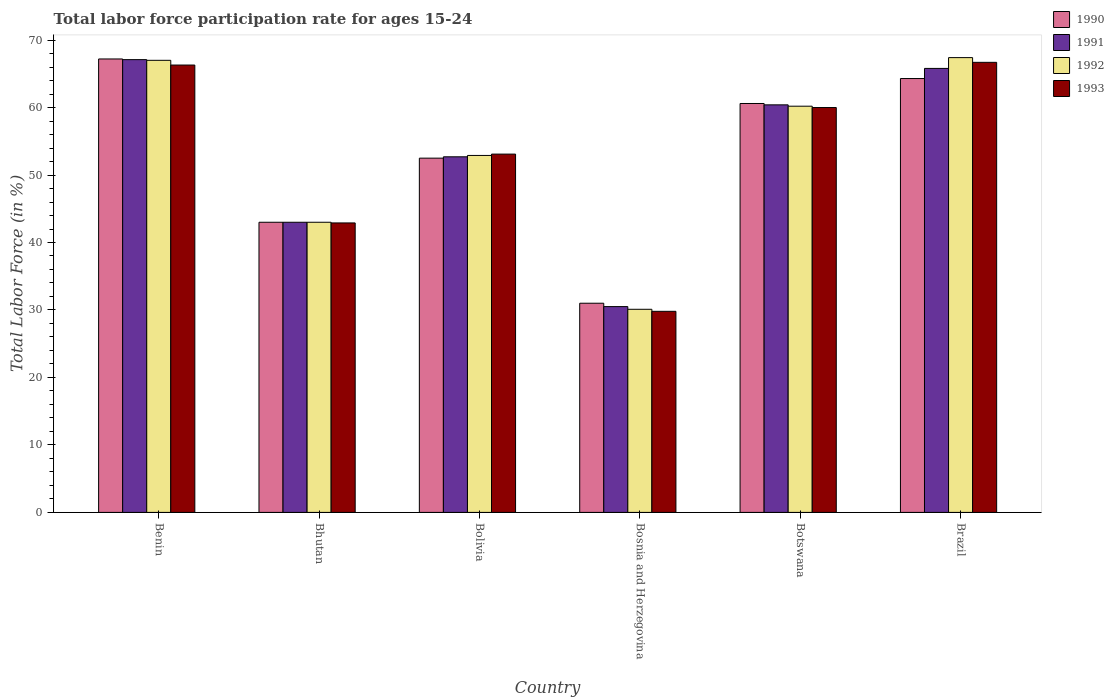How many different coloured bars are there?
Offer a very short reply. 4. How many groups of bars are there?
Offer a very short reply. 6. Are the number of bars per tick equal to the number of legend labels?
Make the answer very short. Yes. Are the number of bars on each tick of the X-axis equal?
Your answer should be compact. Yes. How many bars are there on the 1st tick from the right?
Your response must be concise. 4. What is the label of the 2nd group of bars from the left?
Offer a terse response. Bhutan. In how many cases, is the number of bars for a given country not equal to the number of legend labels?
Provide a succinct answer. 0. What is the labor force participation rate in 1990 in Brazil?
Offer a very short reply. 64.3. Across all countries, what is the maximum labor force participation rate in 1992?
Your response must be concise. 67.4. Across all countries, what is the minimum labor force participation rate in 1993?
Your answer should be very brief. 29.8. In which country was the labor force participation rate in 1990 minimum?
Make the answer very short. Bosnia and Herzegovina. What is the total labor force participation rate in 1993 in the graph?
Provide a short and direct response. 318.8. What is the difference between the labor force participation rate in 1992 in Bosnia and Herzegovina and that in Botswana?
Provide a succinct answer. -30.1. What is the difference between the labor force participation rate in 1991 in Botswana and the labor force participation rate in 1993 in Benin?
Give a very brief answer. -5.9. What is the average labor force participation rate in 1993 per country?
Offer a very short reply. 53.13. What is the difference between the labor force participation rate of/in 1990 and labor force participation rate of/in 1993 in Bosnia and Herzegovina?
Give a very brief answer. 1.2. What is the ratio of the labor force participation rate in 1992 in Botswana to that in Brazil?
Offer a terse response. 0.89. Is the labor force participation rate in 1992 in Bolivia less than that in Bosnia and Herzegovina?
Offer a very short reply. No. What is the difference between the highest and the second highest labor force participation rate in 1991?
Provide a short and direct response. -1.3. What is the difference between the highest and the lowest labor force participation rate in 1990?
Your answer should be very brief. 36.2. In how many countries, is the labor force participation rate in 1993 greater than the average labor force participation rate in 1993 taken over all countries?
Provide a short and direct response. 3. Is the sum of the labor force participation rate in 1993 in Bhutan and Brazil greater than the maximum labor force participation rate in 1991 across all countries?
Your answer should be very brief. Yes. Is it the case that in every country, the sum of the labor force participation rate in 1992 and labor force participation rate in 1993 is greater than the sum of labor force participation rate in 1990 and labor force participation rate in 1991?
Provide a succinct answer. No. What does the 2nd bar from the left in Botswana represents?
Ensure brevity in your answer.  1991. How many bars are there?
Offer a terse response. 24. What is the difference between two consecutive major ticks on the Y-axis?
Give a very brief answer. 10. Are the values on the major ticks of Y-axis written in scientific E-notation?
Offer a terse response. No. Does the graph contain any zero values?
Make the answer very short. No. Does the graph contain grids?
Keep it short and to the point. No. Where does the legend appear in the graph?
Give a very brief answer. Top right. How are the legend labels stacked?
Your response must be concise. Vertical. What is the title of the graph?
Ensure brevity in your answer.  Total labor force participation rate for ages 15-24. Does "1999" appear as one of the legend labels in the graph?
Provide a short and direct response. No. What is the label or title of the Y-axis?
Provide a succinct answer. Total Labor Force (in %). What is the Total Labor Force (in %) of 1990 in Benin?
Your answer should be very brief. 67.2. What is the Total Labor Force (in %) in 1991 in Benin?
Make the answer very short. 67.1. What is the Total Labor Force (in %) in 1993 in Benin?
Provide a succinct answer. 66.3. What is the Total Labor Force (in %) of 1992 in Bhutan?
Give a very brief answer. 43. What is the Total Labor Force (in %) of 1993 in Bhutan?
Your answer should be very brief. 42.9. What is the Total Labor Force (in %) in 1990 in Bolivia?
Offer a terse response. 52.5. What is the Total Labor Force (in %) in 1991 in Bolivia?
Give a very brief answer. 52.7. What is the Total Labor Force (in %) of 1992 in Bolivia?
Provide a short and direct response. 52.9. What is the Total Labor Force (in %) of 1993 in Bolivia?
Your response must be concise. 53.1. What is the Total Labor Force (in %) in 1990 in Bosnia and Herzegovina?
Offer a terse response. 31. What is the Total Labor Force (in %) of 1991 in Bosnia and Herzegovina?
Offer a very short reply. 30.5. What is the Total Labor Force (in %) in 1992 in Bosnia and Herzegovina?
Your answer should be very brief. 30.1. What is the Total Labor Force (in %) in 1993 in Bosnia and Herzegovina?
Give a very brief answer. 29.8. What is the Total Labor Force (in %) in 1990 in Botswana?
Give a very brief answer. 60.6. What is the Total Labor Force (in %) of 1991 in Botswana?
Offer a terse response. 60.4. What is the Total Labor Force (in %) of 1992 in Botswana?
Ensure brevity in your answer.  60.2. What is the Total Labor Force (in %) of 1990 in Brazil?
Offer a terse response. 64.3. What is the Total Labor Force (in %) of 1991 in Brazil?
Keep it short and to the point. 65.8. What is the Total Labor Force (in %) of 1992 in Brazil?
Make the answer very short. 67.4. What is the Total Labor Force (in %) of 1993 in Brazil?
Your answer should be compact. 66.7. Across all countries, what is the maximum Total Labor Force (in %) in 1990?
Give a very brief answer. 67.2. Across all countries, what is the maximum Total Labor Force (in %) of 1991?
Give a very brief answer. 67.1. Across all countries, what is the maximum Total Labor Force (in %) of 1992?
Ensure brevity in your answer.  67.4. Across all countries, what is the maximum Total Labor Force (in %) of 1993?
Provide a short and direct response. 66.7. Across all countries, what is the minimum Total Labor Force (in %) in 1991?
Your answer should be very brief. 30.5. Across all countries, what is the minimum Total Labor Force (in %) of 1992?
Provide a short and direct response. 30.1. Across all countries, what is the minimum Total Labor Force (in %) of 1993?
Your answer should be compact. 29.8. What is the total Total Labor Force (in %) of 1990 in the graph?
Offer a very short reply. 318.6. What is the total Total Labor Force (in %) in 1991 in the graph?
Offer a very short reply. 319.5. What is the total Total Labor Force (in %) in 1992 in the graph?
Offer a terse response. 320.6. What is the total Total Labor Force (in %) of 1993 in the graph?
Your answer should be compact. 318.8. What is the difference between the Total Labor Force (in %) of 1990 in Benin and that in Bhutan?
Your answer should be compact. 24.2. What is the difference between the Total Labor Force (in %) of 1991 in Benin and that in Bhutan?
Offer a terse response. 24.1. What is the difference between the Total Labor Force (in %) in 1992 in Benin and that in Bhutan?
Ensure brevity in your answer.  24. What is the difference between the Total Labor Force (in %) in 1993 in Benin and that in Bhutan?
Your answer should be compact. 23.4. What is the difference between the Total Labor Force (in %) of 1992 in Benin and that in Bolivia?
Offer a terse response. 14.1. What is the difference between the Total Labor Force (in %) in 1993 in Benin and that in Bolivia?
Offer a terse response. 13.2. What is the difference between the Total Labor Force (in %) in 1990 in Benin and that in Bosnia and Herzegovina?
Your answer should be compact. 36.2. What is the difference between the Total Labor Force (in %) in 1991 in Benin and that in Bosnia and Herzegovina?
Offer a terse response. 36.6. What is the difference between the Total Labor Force (in %) of 1992 in Benin and that in Bosnia and Herzegovina?
Offer a very short reply. 36.9. What is the difference between the Total Labor Force (in %) in 1993 in Benin and that in Bosnia and Herzegovina?
Offer a very short reply. 36.5. What is the difference between the Total Labor Force (in %) in 1991 in Benin and that in Botswana?
Your answer should be compact. 6.7. What is the difference between the Total Labor Force (in %) in 1993 in Benin and that in Botswana?
Make the answer very short. 6.3. What is the difference between the Total Labor Force (in %) of 1992 in Benin and that in Brazil?
Make the answer very short. -0.4. What is the difference between the Total Labor Force (in %) of 1993 in Benin and that in Brazil?
Give a very brief answer. -0.4. What is the difference between the Total Labor Force (in %) of 1990 in Bhutan and that in Bolivia?
Ensure brevity in your answer.  -9.5. What is the difference between the Total Labor Force (in %) of 1991 in Bhutan and that in Bolivia?
Offer a terse response. -9.7. What is the difference between the Total Labor Force (in %) of 1990 in Bhutan and that in Botswana?
Provide a short and direct response. -17.6. What is the difference between the Total Labor Force (in %) in 1991 in Bhutan and that in Botswana?
Provide a short and direct response. -17.4. What is the difference between the Total Labor Force (in %) in 1992 in Bhutan and that in Botswana?
Ensure brevity in your answer.  -17.2. What is the difference between the Total Labor Force (in %) in 1993 in Bhutan and that in Botswana?
Provide a short and direct response. -17.1. What is the difference between the Total Labor Force (in %) of 1990 in Bhutan and that in Brazil?
Keep it short and to the point. -21.3. What is the difference between the Total Labor Force (in %) in 1991 in Bhutan and that in Brazil?
Offer a terse response. -22.8. What is the difference between the Total Labor Force (in %) of 1992 in Bhutan and that in Brazil?
Your response must be concise. -24.4. What is the difference between the Total Labor Force (in %) of 1993 in Bhutan and that in Brazil?
Offer a terse response. -23.8. What is the difference between the Total Labor Force (in %) in 1992 in Bolivia and that in Bosnia and Herzegovina?
Your answer should be compact. 22.8. What is the difference between the Total Labor Force (in %) in 1993 in Bolivia and that in Bosnia and Herzegovina?
Offer a terse response. 23.3. What is the difference between the Total Labor Force (in %) of 1990 in Bolivia and that in Botswana?
Offer a very short reply. -8.1. What is the difference between the Total Labor Force (in %) in 1992 in Bolivia and that in Botswana?
Your response must be concise. -7.3. What is the difference between the Total Labor Force (in %) of 1993 in Bolivia and that in Botswana?
Ensure brevity in your answer.  -6.9. What is the difference between the Total Labor Force (in %) in 1992 in Bolivia and that in Brazil?
Keep it short and to the point. -14.5. What is the difference between the Total Labor Force (in %) of 1993 in Bolivia and that in Brazil?
Give a very brief answer. -13.6. What is the difference between the Total Labor Force (in %) of 1990 in Bosnia and Herzegovina and that in Botswana?
Keep it short and to the point. -29.6. What is the difference between the Total Labor Force (in %) of 1991 in Bosnia and Herzegovina and that in Botswana?
Make the answer very short. -29.9. What is the difference between the Total Labor Force (in %) in 1992 in Bosnia and Herzegovina and that in Botswana?
Ensure brevity in your answer.  -30.1. What is the difference between the Total Labor Force (in %) in 1993 in Bosnia and Herzegovina and that in Botswana?
Your answer should be very brief. -30.2. What is the difference between the Total Labor Force (in %) in 1990 in Bosnia and Herzegovina and that in Brazil?
Your answer should be very brief. -33.3. What is the difference between the Total Labor Force (in %) in 1991 in Bosnia and Herzegovina and that in Brazil?
Your answer should be very brief. -35.3. What is the difference between the Total Labor Force (in %) of 1992 in Bosnia and Herzegovina and that in Brazil?
Provide a succinct answer. -37.3. What is the difference between the Total Labor Force (in %) of 1993 in Bosnia and Herzegovina and that in Brazil?
Your response must be concise. -36.9. What is the difference between the Total Labor Force (in %) in 1990 in Botswana and that in Brazil?
Make the answer very short. -3.7. What is the difference between the Total Labor Force (in %) in 1990 in Benin and the Total Labor Force (in %) in 1991 in Bhutan?
Make the answer very short. 24.2. What is the difference between the Total Labor Force (in %) of 1990 in Benin and the Total Labor Force (in %) of 1992 in Bhutan?
Offer a very short reply. 24.2. What is the difference between the Total Labor Force (in %) in 1990 in Benin and the Total Labor Force (in %) in 1993 in Bhutan?
Make the answer very short. 24.3. What is the difference between the Total Labor Force (in %) of 1991 in Benin and the Total Labor Force (in %) of 1992 in Bhutan?
Offer a terse response. 24.1. What is the difference between the Total Labor Force (in %) in 1991 in Benin and the Total Labor Force (in %) in 1993 in Bhutan?
Provide a succinct answer. 24.2. What is the difference between the Total Labor Force (in %) of 1992 in Benin and the Total Labor Force (in %) of 1993 in Bhutan?
Your response must be concise. 24.1. What is the difference between the Total Labor Force (in %) of 1990 in Benin and the Total Labor Force (in %) of 1992 in Bolivia?
Your answer should be compact. 14.3. What is the difference between the Total Labor Force (in %) of 1990 in Benin and the Total Labor Force (in %) of 1991 in Bosnia and Herzegovina?
Ensure brevity in your answer.  36.7. What is the difference between the Total Labor Force (in %) in 1990 in Benin and the Total Labor Force (in %) in 1992 in Bosnia and Herzegovina?
Keep it short and to the point. 37.1. What is the difference between the Total Labor Force (in %) of 1990 in Benin and the Total Labor Force (in %) of 1993 in Bosnia and Herzegovina?
Your answer should be very brief. 37.4. What is the difference between the Total Labor Force (in %) of 1991 in Benin and the Total Labor Force (in %) of 1992 in Bosnia and Herzegovina?
Your answer should be compact. 37. What is the difference between the Total Labor Force (in %) of 1991 in Benin and the Total Labor Force (in %) of 1993 in Bosnia and Herzegovina?
Make the answer very short. 37.3. What is the difference between the Total Labor Force (in %) of 1992 in Benin and the Total Labor Force (in %) of 1993 in Bosnia and Herzegovina?
Your answer should be compact. 37.2. What is the difference between the Total Labor Force (in %) of 1990 in Benin and the Total Labor Force (in %) of 1991 in Botswana?
Keep it short and to the point. 6.8. What is the difference between the Total Labor Force (in %) in 1991 in Benin and the Total Labor Force (in %) in 1992 in Botswana?
Ensure brevity in your answer.  6.9. What is the difference between the Total Labor Force (in %) in 1991 in Benin and the Total Labor Force (in %) in 1993 in Botswana?
Provide a succinct answer. 7.1. What is the difference between the Total Labor Force (in %) in 1990 in Benin and the Total Labor Force (in %) in 1991 in Brazil?
Make the answer very short. 1.4. What is the difference between the Total Labor Force (in %) of 1991 in Benin and the Total Labor Force (in %) of 1992 in Brazil?
Your answer should be very brief. -0.3. What is the difference between the Total Labor Force (in %) in 1991 in Benin and the Total Labor Force (in %) in 1993 in Brazil?
Provide a short and direct response. 0.4. What is the difference between the Total Labor Force (in %) of 1992 in Bhutan and the Total Labor Force (in %) of 1993 in Bolivia?
Ensure brevity in your answer.  -10.1. What is the difference between the Total Labor Force (in %) of 1990 in Bhutan and the Total Labor Force (in %) of 1993 in Bosnia and Herzegovina?
Provide a short and direct response. 13.2. What is the difference between the Total Labor Force (in %) of 1991 in Bhutan and the Total Labor Force (in %) of 1992 in Bosnia and Herzegovina?
Ensure brevity in your answer.  12.9. What is the difference between the Total Labor Force (in %) in 1991 in Bhutan and the Total Labor Force (in %) in 1993 in Bosnia and Herzegovina?
Your response must be concise. 13.2. What is the difference between the Total Labor Force (in %) of 1990 in Bhutan and the Total Labor Force (in %) of 1991 in Botswana?
Provide a succinct answer. -17.4. What is the difference between the Total Labor Force (in %) in 1990 in Bhutan and the Total Labor Force (in %) in 1992 in Botswana?
Your answer should be very brief. -17.2. What is the difference between the Total Labor Force (in %) in 1991 in Bhutan and the Total Labor Force (in %) in 1992 in Botswana?
Make the answer very short. -17.2. What is the difference between the Total Labor Force (in %) in 1990 in Bhutan and the Total Labor Force (in %) in 1991 in Brazil?
Your response must be concise. -22.8. What is the difference between the Total Labor Force (in %) in 1990 in Bhutan and the Total Labor Force (in %) in 1992 in Brazil?
Ensure brevity in your answer.  -24.4. What is the difference between the Total Labor Force (in %) of 1990 in Bhutan and the Total Labor Force (in %) of 1993 in Brazil?
Make the answer very short. -23.7. What is the difference between the Total Labor Force (in %) of 1991 in Bhutan and the Total Labor Force (in %) of 1992 in Brazil?
Your response must be concise. -24.4. What is the difference between the Total Labor Force (in %) of 1991 in Bhutan and the Total Labor Force (in %) of 1993 in Brazil?
Ensure brevity in your answer.  -23.7. What is the difference between the Total Labor Force (in %) of 1992 in Bhutan and the Total Labor Force (in %) of 1993 in Brazil?
Give a very brief answer. -23.7. What is the difference between the Total Labor Force (in %) of 1990 in Bolivia and the Total Labor Force (in %) of 1991 in Bosnia and Herzegovina?
Your answer should be very brief. 22. What is the difference between the Total Labor Force (in %) in 1990 in Bolivia and the Total Labor Force (in %) in 1992 in Bosnia and Herzegovina?
Offer a terse response. 22.4. What is the difference between the Total Labor Force (in %) in 1990 in Bolivia and the Total Labor Force (in %) in 1993 in Bosnia and Herzegovina?
Keep it short and to the point. 22.7. What is the difference between the Total Labor Force (in %) in 1991 in Bolivia and the Total Labor Force (in %) in 1992 in Bosnia and Herzegovina?
Your response must be concise. 22.6. What is the difference between the Total Labor Force (in %) of 1991 in Bolivia and the Total Labor Force (in %) of 1993 in Bosnia and Herzegovina?
Make the answer very short. 22.9. What is the difference between the Total Labor Force (in %) in 1992 in Bolivia and the Total Labor Force (in %) in 1993 in Bosnia and Herzegovina?
Make the answer very short. 23.1. What is the difference between the Total Labor Force (in %) of 1990 in Bolivia and the Total Labor Force (in %) of 1991 in Botswana?
Your answer should be very brief. -7.9. What is the difference between the Total Labor Force (in %) in 1990 in Bolivia and the Total Labor Force (in %) in 1992 in Botswana?
Make the answer very short. -7.7. What is the difference between the Total Labor Force (in %) of 1991 in Bolivia and the Total Labor Force (in %) of 1993 in Botswana?
Provide a short and direct response. -7.3. What is the difference between the Total Labor Force (in %) in 1990 in Bolivia and the Total Labor Force (in %) in 1992 in Brazil?
Make the answer very short. -14.9. What is the difference between the Total Labor Force (in %) of 1991 in Bolivia and the Total Labor Force (in %) of 1992 in Brazil?
Make the answer very short. -14.7. What is the difference between the Total Labor Force (in %) of 1991 in Bolivia and the Total Labor Force (in %) of 1993 in Brazil?
Ensure brevity in your answer.  -14. What is the difference between the Total Labor Force (in %) in 1992 in Bolivia and the Total Labor Force (in %) in 1993 in Brazil?
Provide a short and direct response. -13.8. What is the difference between the Total Labor Force (in %) in 1990 in Bosnia and Herzegovina and the Total Labor Force (in %) in 1991 in Botswana?
Provide a succinct answer. -29.4. What is the difference between the Total Labor Force (in %) of 1990 in Bosnia and Herzegovina and the Total Labor Force (in %) of 1992 in Botswana?
Offer a very short reply. -29.2. What is the difference between the Total Labor Force (in %) of 1990 in Bosnia and Herzegovina and the Total Labor Force (in %) of 1993 in Botswana?
Offer a terse response. -29. What is the difference between the Total Labor Force (in %) of 1991 in Bosnia and Herzegovina and the Total Labor Force (in %) of 1992 in Botswana?
Make the answer very short. -29.7. What is the difference between the Total Labor Force (in %) in 1991 in Bosnia and Herzegovina and the Total Labor Force (in %) in 1993 in Botswana?
Your answer should be very brief. -29.5. What is the difference between the Total Labor Force (in %) of 1992 in Bosnia and Herzegovina and the Total Labor Force (in %) of 1993 in Botswana?
Offer a very short reply. -29.9. What is the difference between the Total Labor Force (in %) of 1990 in Bosnia and Herzegovina and the Total Labor Force (in %) of 1991 in Brazil?
Your response must be concise. -34.8. What is the difference between the Total Labor Force (in %) in 1990 in Bosnia and Herzegovina and the Total Labor Force (in %) in 1992 in Brazil?
Provide a short and direct response. -36.4. What is the difference between the Total Labor Force (in %) in 1990 in Bosnia and Herzegovina and the Total Labor Force (in %) in 1993 in Brazil?
Make the answer very short. -35.7. What is the difference between the Total Labor Force (in %) of 1991 in Bosnia and Herzegovina and the Total Labor Force (in %) of 1992 in Brazil?
Your response must be concise. -36.9. What is the difference between the Total Labor Force (in %) in 1991 in Bosnia and Herzegovina and the Total Labor Force (in %) in 1993 in Brazil?
Your answer should be very brief. -36.2. What is the difference between the Total Labor Force (in %) of 1992 in Bosnia and Herzegovina and the Total Labor Force (in %) of 1993 in Brazil?
Offer a very short reply. -36.6. What is the difference between the Total Labor Force (in %) of 1990 in Botswana and the Total Labor Force (in %) of 1993 in Brazil?
Your response must be concise. -6.1. What is the difference between the Total Labor Force (in %) of 1991 in Botswana and the Total Labor Force (in %) of 1992 in Brazil?
Your answer should be very brief. -7. What is the average Total Labor Force (in %) of 1990 per country?
Your answer should be very brief. 53.1. What is the average Total Labor Force (in %) of 1991 per country?
Give a very brief answer. 53.25. What is the average Total Labor Force (in %) of 1992 per country?
Ensure brevity in your answer.  53.43. What is the average Total Labor Force (in %) of 1993 per country?
Ensure brevity in your answer.  53.13. What is the difference between the Total Labor Force (in %) of 1990 and Total Labor Force (in %) of 1992 in Benin?
Provide a succinct answer. 0.2. What is the difference between the Total Labor Force (in %) in 1991 and Total Labor Force (in %) in 1992 in Benin?
Make the answer very short. 0.1. What is the difference between the Total Labor Force (in %) of 1991 and Total Labor Force (in %) of 1993 in Benin?
Your response must be concise. 0.8. What is the difference between the Total Labor Force (in %) of 1990 and Total Labor Force (in %) of 1992 in Bhutan?
Provide a succinct answer. 0. What is the difference between the Total Labor Force (in %) of 1991 and Total Labor Force (in %) of 1992 in Bhutan?
Offer a very short reply. 0. What is the difference between the Total Labor Force (in %) in 1991 and Total Labor Force (in %) in 1993 in Bhutan?
Keep it short and to the point. 0.1. What is the difference between the Total Labor Force (in %) in 1992 and Total Labor Force (in %) in 1993 in Bhutan?
Provide a short and direct response. 0.1. What is the difference between the Total Labor Force (in %) in 1990 and Total Labor Force (in %) in 1991 in Bolivia?
Provide a short and direct response. -0.2. What is the difference between the Total Labor Force (in %) in 1991 and Total Labor Force (in %) in 1992 in Bolivia?
Offer a terse response. -0.2. What is the difference between the Total Labor Force (in %) in 1991 and Total Labor Force (in %) in 1993 in Bolivia?
Offer a terse response. -0.4. What is the difference between the Total Labor Force (in %) of 1992 and Total Labor Force (in %) of 1993 in Bolivia?
Your answer should be very brief. -0.2. What is the difference between the Total Labor Force (in %) of 1990 and Total Labor Force (in %) of 1991 in Bosnia and Herzegovina?
Make the answer very short. 0.5. What is the difference between the Total Labor Force (in %) of 1990 and Total Labor Force (in %) of 1993 in Bosnia and Herzegovina?
Keep it short and to the point. 1.2. What is the difference between the Total Labor Force (in %) in 1990 and Total Labor Force (in %) in 1991 in Botswana?
Offer a very short reply. 0.2. What is the difference between the Total Labor Force (in %) in 1990 and Total Labor Force (in %) in 1991 in Brazil?
Your answer should be compact. -1.5. What is the difference between the Total Labor Force (in %) of 1990 and Total Labor Force (in %) of 1992 in Brazil?
Provide a succinct answer. -3.1. What is the difference between the Total Labor Force (in %) in 1991 and Total Labor Force (in %) in 1993 in Brazil?
Give a very brief answer. -0.9. What is the ratio of the Total Labor Force (in %) of 1990 in Benin to that in Bhutan?
Provide a short and direct response. 1.56. What is the ratio of the Total Labor Force (in %) of 1991 in Benin to that in Bhutan?
Keep it short and to the point. 1.56. What is the ratio of the Total Labor Force (in %) of 1992 in Benin to that in Bhutan?
Your answer should be compact. 1.56. What is the ratio of the Total Labor Force (in %) in 1993 in Benin to that in Bhutan?
Make the answer very short. 1.55. What is the ratio of the Total Labor Force (in %) in 1990 in Benin to that in Bolivia?
Your answer should be very brief. 1.28. What is the ratio of the Total Labor Force (in %) in 1991 in Benin to that in Bolivia?
Your answer should be very brief. 1.27. What is the ratio of the Total Labor Force (in %) of 1992 in Benin to that in Bolivia?
Keep it short and to the point. 1.27. What is the ratio of the Total Labor Force (in %) of 1993 in Benin to that in Bolivia?
Your response must be concise. 1.25. What is the ratio of the Total Labor Force (in %) of 1990 in Benin to that in Bosnia and Herzegovina?
Keep it short and to the point. 2.17. What is the ratio of the Total Labor Force (in %) in 1991 in Benin to that in Bosnia and Herzegovina?
Give a very brief answer. 2.2. What is the ratio of the Total Labor Force (in %) of 1992 in Benin to that in Bosnia and Herzegovina?
Offer a very short reply. 2.23. What is the ratio of the Total Labor Force (in %) of 1993 in Benin to that in Bosnia and Herzegovina?
Provide a short and direct response. 2.22. What is the ratio of the Total Labor Force (in %) in 1990 in Benin to that in Botswana?
Ensure brevity in your answer.  1.11. What is the ratio of the Total Labor Force (in %) in 1991 in Benin to that in Botswana?
Your answer should be compact. 1.11. What is the ratio of the Total Labor Force (in %) in 1992 in Benin to that in Botswana?
Provide a short and direct response. 1.11. What is the ratio of the Total Labor Force (in %) of 1993 in Benin to that in Botswana?
Make the answer very short. 1.1. What is the ratio of the Total Labor Force (in %) in 1990 in Benin to that in Brazil?
Ensure brevity in your answer.  1.05. What is the ratio of the Total Labor Force (in %) in 1991 in Benin to that in Brazil?
Offer a terse response. 1.02. What is the ratio of the Total Labor Force (in %) in 1990 in Bhutan to that in Bolivia?
Keep it short and to the point. 0.82. What is the ratio of the Total Labor Force (in %) in 1991 in Bhutan to that in Bolivia?
Provide a short and direct response. 0.82. What is the ratio of the Total Labor Force (in %) in 1992 in Bhutan to that in Bolivia?
Provide a succinct answer. 0.81. What is the ratio of the Total Labor Force (in %) in 1993 in Bhutan to that in Bolivia?
Ensure brevity in your answer.  0.81. What is the ratio of the Total Labor Force (in %) of 1990 in Bhutan to that in Bosnia and Herzegovina?
Keep it short and to the point. 1.39. What is the ratio of the Total Labor Force (in %) in 1991 in Bhutan to that in Bosnia and Herzegovina?
Keep it short and to the point. 1.41. What is the ratio of the Total Labor Force (in %) of 1992 in Bhutan to that in Bosnia and Herzegovina?
Keep it short and to the point. 1.43. What is the ratio of the Total Labor Force (in %) of 1993 in Bhutan to that in Bosnia and Herzegovina?
Your response must be concise. 1.44. What is the ratio of the Total Labor Force (in %) in 1990 in Bhutan to that in Botswana?
Keep it short and to the point. 0.71. What is the ratio of the Total Labor Force (in %) of 1991 in Bhutan to that in Botswana?
Offer a very short reply. 0.71. What is the ratio of the Total Labor Force (in %) in 1993 in Bhutan to that in Botswana?
Your response must be concise. 0.71. What is the ratio of the Total Labor Force (in %) in 1990 in Bhutan to that in Brazil?
Ensure brevity in your answer.  0.67. What is the ratio of the Total Labor Force (in %) in 1991 in Bhutan to that in Brazil?
Offer a terse response. 0.65. What is the ratio of the Total Labor Force (in %) in 1992 in Bhutan to that in Brazil?
Your response must be concise. 0.64. What is the ratio of the Total Labor Force (in %) in 1993 in Bhutan to that in Brazil?
Give a very brief answer. 0.64. What is the ratio of the Total Labor Force (in %) in 1990 in Bolivia to that in Bosnia and Herzegovina?
Ensure brevity in your answer.  1.69. What is the ratio of the Total Labor Force (in %) of 1991 in Bolivia to that in Bosnia and Herzegovina?
Offer a terse response. 1.73. What is the ratio of the Total Labor Force (in %) of 1992 in Bolivia to that in Bosnia and Herzegovina?
Make the answer very short. 1.76. What is the ratio of the Total Labor Force (in %) in 1993 in Bolivia to that in Bosnia and Herzegovina?
Make the answer very short. 1.78. What is the ratio of the Total Labor Force (in %) in 1990 in Bolivia to that in Botswana?
Give a very brief answer. 0.87. What is the ratio of the Total Labor Force (in %) in 1991 in Bolivia to that in Botswana?
Keep it short and to the point. 0.87. What is the ratio of the Total Labor Force (in %) of 1992 in Bolivia to that in Botswana?
Your answer should be very brief. 0.88. What is the ratio of the Total Labor Force (in %) in 1993 in Bolivia to that in Botswana?
Keep it short and to the point. 0.89. What is the ratio of the Total Labor Force (in %) of 1990 in Bolivia to that in Brazil?
Offer a terse response. 0.82. What is the ratio of the Total Labor Force (in %) of 1991 in Bolivia to that in Brazil?
Offer a very short reply. 0.8. What is the ratio of the Total Labor Force (in %) of 1992 in Bolivia to that in Brazil?
Keep it short and to the point. 0.78. What is the ratio of the Total Labor Force (in %) in 1993 in Bolivia to that in Brazil?
Make the answer very short. 0.8. What is the ratio of the Total Labor Force (in %) in 1990 in Bosnia and Herzegovina to that in Botswana?
Your response must be concise. 0.51. What is the ratio of the Total Labor Force (in %) of 1991 in Bosnia and Herzegovina to that in Botswana?
Your answer should be very brief. 0.51. What is the ratio of the Total Labor Force (in %) in 1993 in Bosnia and Herzegovina to that in Botswana?
Offer a very short reply. 0.5. What is the ratio of the Total Labor Force (in %) of 1990 in Bosnia and Herzegovina to that in Brazil?
Your answer should be very brief. 0.48. What is the ratio of the Total Labor Force (in %) in 1991 in Bosnia and Herzegovina to that in Brazil?
Offer a terse response. 0.46. What is the ratio of the Total Labor Force (in %) in 1992 in Bosnia and Herzegovina to that in Brazil?
Make the answer very short. 0.45. What is the ratio of the Total Labor Force (in %) of 1993 in Bosnia and Herzegovina to that in Brazil?
Your answer should be very brief. 0.45. What is the ratio of the Total Labor Force (in %) of 1990 in Botswana to that in Brazil?
Make the answer very short. 0.94. What is the ratio of the Total Labor Force (in %) of 1991 in Botswana to that in Brazil?
Make the answer very short. 0.92. What is the ratio of the Total Labor Force (in %) in 1992 in Botswana to that in Brazil?
Ensure brevity in your answer.  0.89. What is the ratio of the Total Labor Force (in %) of 1993 in Botswana to that in Brazil?
Offer a terse response. 0.9. What is the difference between the highest and the second highest Total Labor Force (in %) of 1991?
Ensure brevity in your answer.  1.3. What is the difference between the highest and the second highest Total Labor Force (in %) of 1993?
Make the answer very short. 0.4. What is the difference between the highest and the lowest Total Labor Force (in %) of 1990?
Provide a succinct answer. 36.2. What is the difference between the highest and the lowest Total Labor Force (in %) in 1991?
Offer a terse response. 36.6. What is the difference between the highest and the lowest Total Labor Force (in %) of 1992?
Ensure brevity in your answer.  37.3. What is the difference between the highest and the lowest Total Labor Force (in %) in 1993?
Provide a short and direct response. 36.9. 